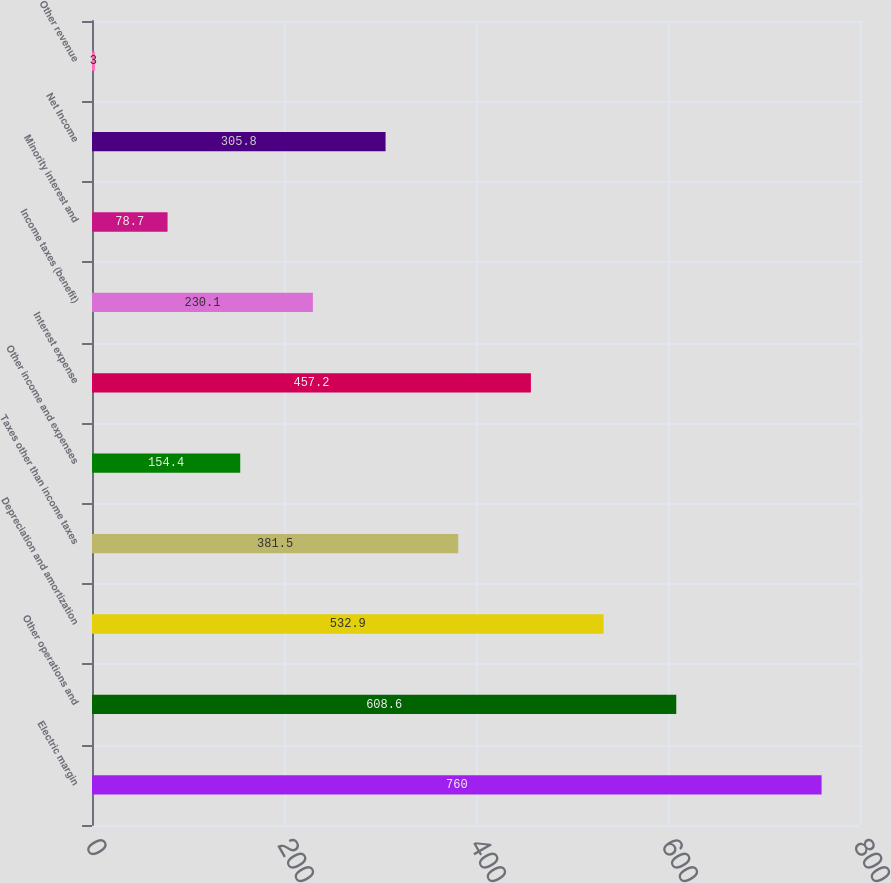Convert chart to OTSL. <chart><loc_0><loc_0><loc_500><loc_500><bar_chart><fcel>Electric margin<fcel>Other operations and<fcel>Depreciation and amortization<fcel>Taxes other than income taxes<fcel>Other income and expenses<fcel>Interest expense<fcel>Income taxes (benefit)<fcel>Minority interest and<fcel>Net Income<fcel>Other revenue<nl><fcel>760<fcel>608.6<fcel>532.9<fcel>381.5<fcel>154.4<fcel>457.2<fcel>230.1<fcel>78.7<fcel>305.8<fcel>3<nl></chart> 